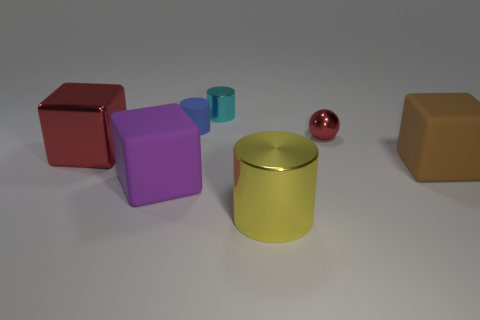How many things are either brown things or cyan metallic objects?
Offer a very short reply. 2. The shiny thing that is the same color as the small metallic sphere is what size?
Offer a very short reply. Large. There is a big yellow metal thing; are there any purple objects to the left of it?
Your answer should be very brief. Yes. Is the number of tiny cylinders that are on the right side of the small blue thing greater than the number of big metal things right of the yellow object?
Provide a short and direct response. Yes. What is the size of the blue thing that is the same shape as the small cyan shiny thing?
Offer a very short reply. Small. What number of cubes are large matte objects or red metal things?
Offer a very short reply. 3. Is the number of large purple matte things that are in front of the metal ball less than the number of objects that are left of the small rubber thing?
Your answer should be very brief. Yes. How many things are objects behind the blue matte object or big rubber things?
Offer a very short reply. 3. There is a large rubber object that is to the left of the metal cylinder behind the purple matte thing; what is its shape?
Your answer should be compact. Cube. Is there a red shiny thing that has the same size as the yellow metal thing?
Provide a short and direct response. Yes. 